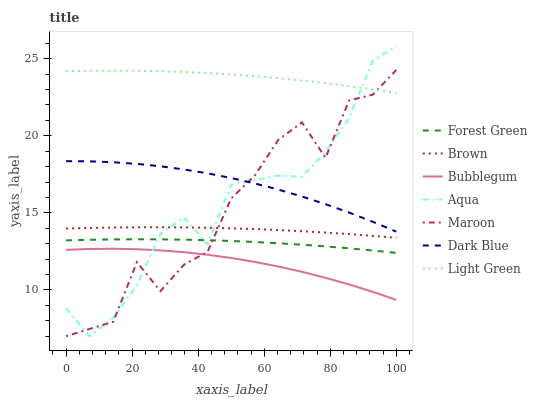Does Bubblegum have the minimum area under the curve?
Answer yes or no. Yes. Does Light Green have the maximum area under the curve?
Answer yes or no. Yes. Does Aqua have the minimum area under the curve?
Answer yes or no. No. Does Aqua have the maximum area under the curve?
Answer yes or no. No. Is Brown the smoothest?
Answer yes or no. Yes. Is Maroon the roughest?
Answer yes or no. Yes. Is Aqua the smoothest?
Answer yes or no. No. Is Aqua the roughest?
Answer yes or no. No. Does Aqua have the lowest value?
Answer yes or no. Yes. Does Dark Blue have the lowest value?
Answer yes or no. No. Does Aqua have the highest value?
Answer yes or no. Yes. Does Maroon have the highest value?
Answer yes or no. No. Is Bubblegum less than Brown?
Answer yes or no. Yes. Is Brown greater than Forest Green?
Answer yes or no. Yes. Does Aqua intersect Dark Blue?
Answer yes or no. Yes. Is Aqua less than Dark Blue?
Answer yes or no. No. Is Aqua greater than Dark Blue?
Answer yes or no. No. Does Bubblegum intersect Brown?
Answer yes or no. No. 